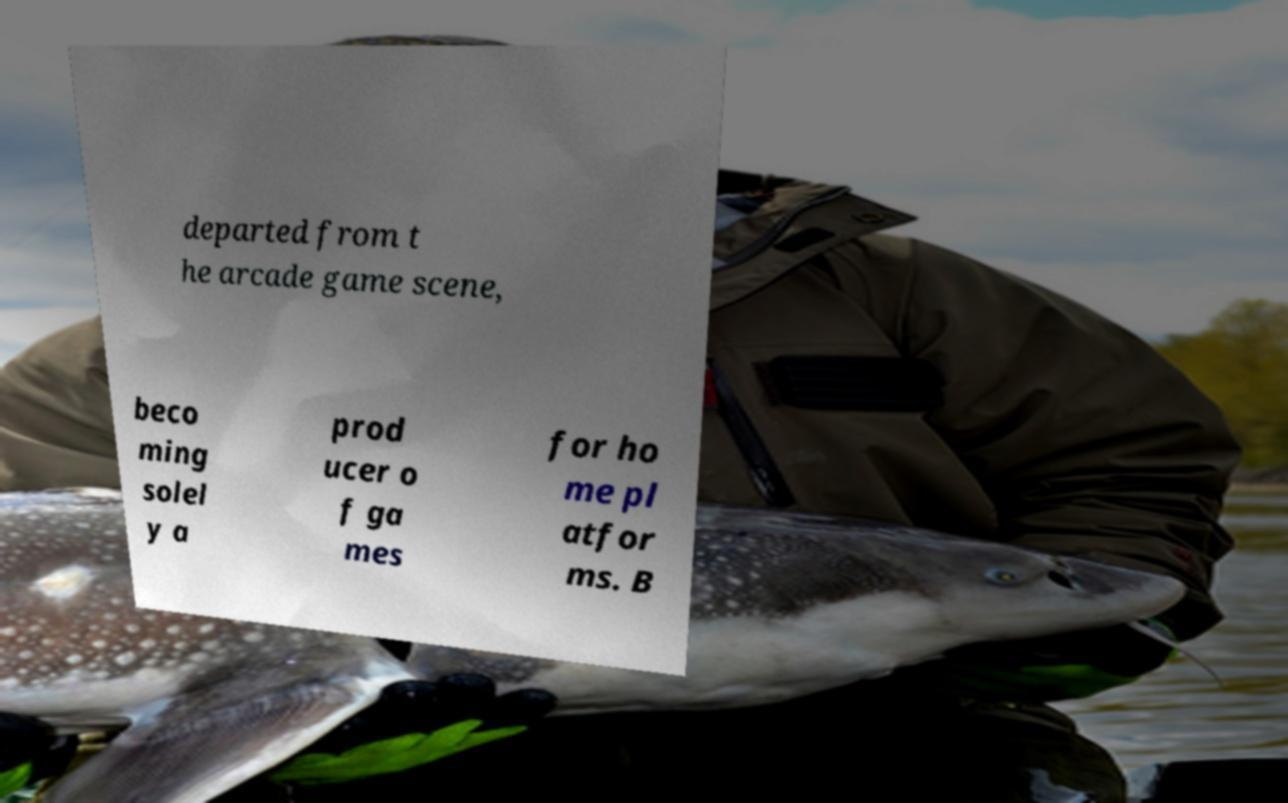Can you accurately transcribe the text from the provided image for me? departed from t he arcade game scene, beco ming solel y a prod ucer o f ga mes for ho me pl atfor ms. B 